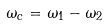<formula> <loc_0><loc_0><loc_500><loc_500>\omega _ { c } = \omega _ { 1 } - \omega _ { 2 }</formula> 